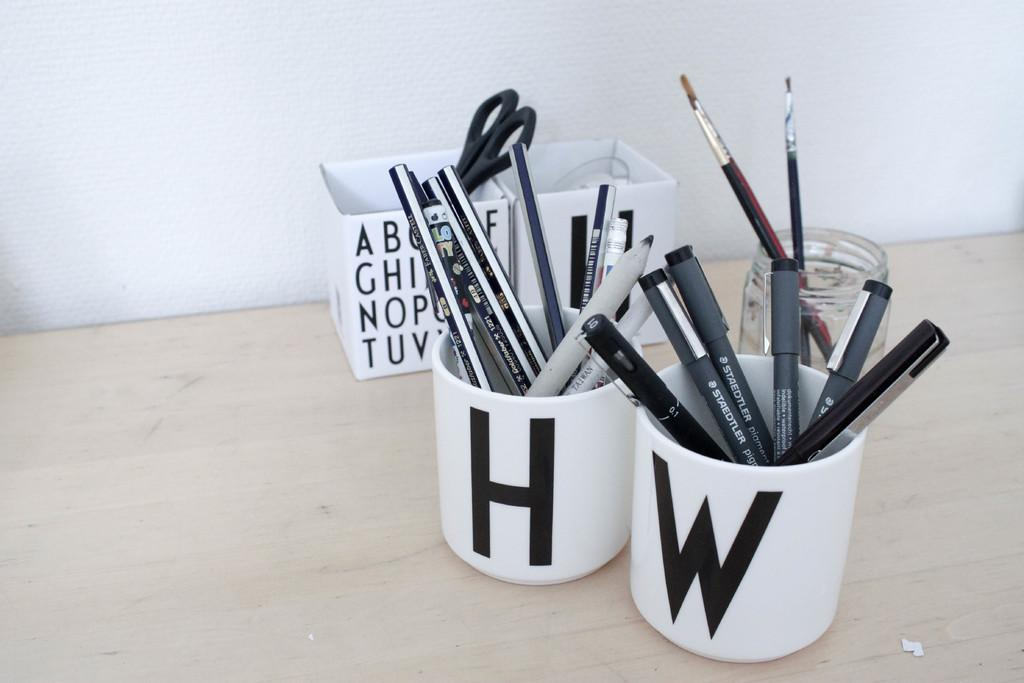What is located on the wooden surface in the image? There is a jar, cups, boxes, pens, pencils, scissors, and paint brushes on the wooden surface in the image. How many objects can be seen on the wooden surface? There are eight objects on the wooden surface: a jar, cups, boxes, pens, pencils, scissors, and paint brushes. What is the background of the image made of? The background of the image is made of a wooden surface. How many cats are sitting on the wooden surface in the image? There are no cats present in the image; it only features a jar, cups, boxes, pens, pencils, scissors, and paint brushes on the wooden surface. What type of cast can be seen on the wooden surface in the image? There is no cast present in the image; it only features a jar, cups, boxes, pens, pencils, scissors, and paint brushes on the wooden surface. 